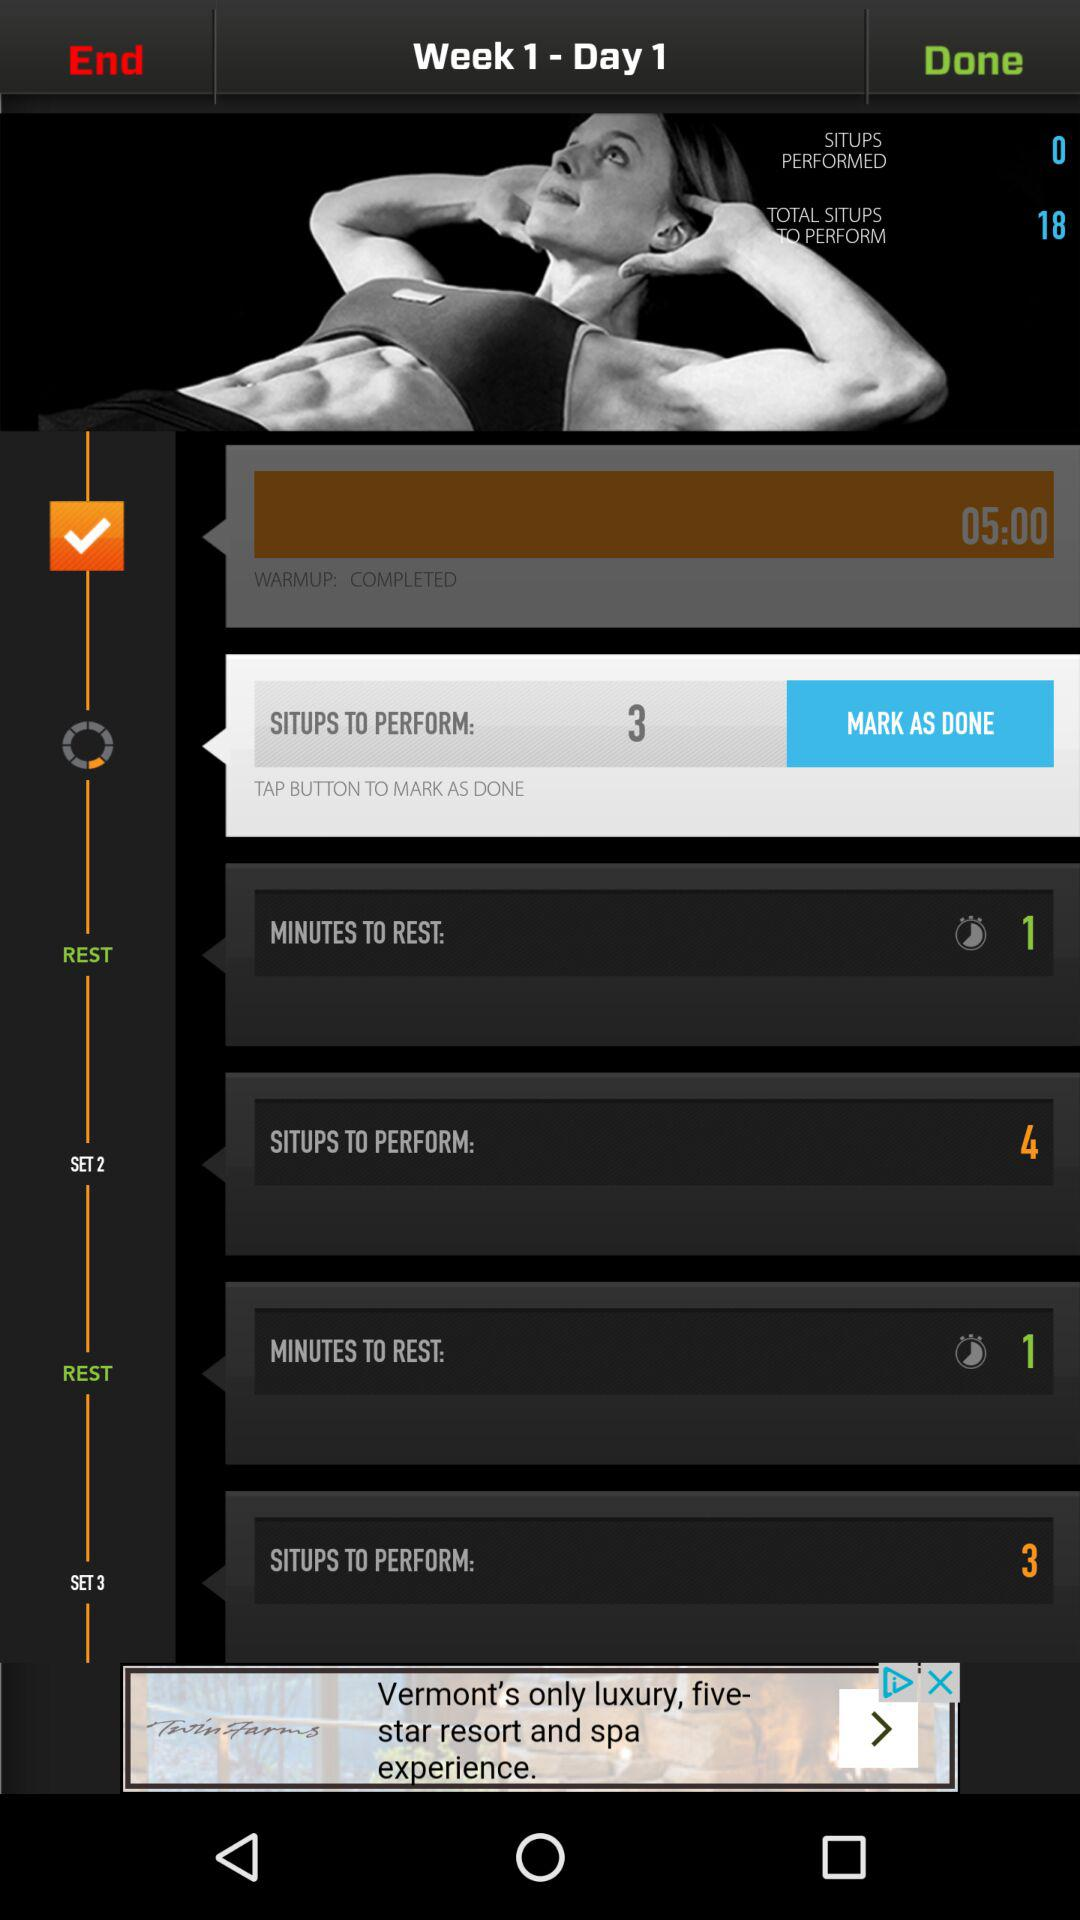How many situps are there to perform in total?
Answer the question using a single word or phrase. 18 